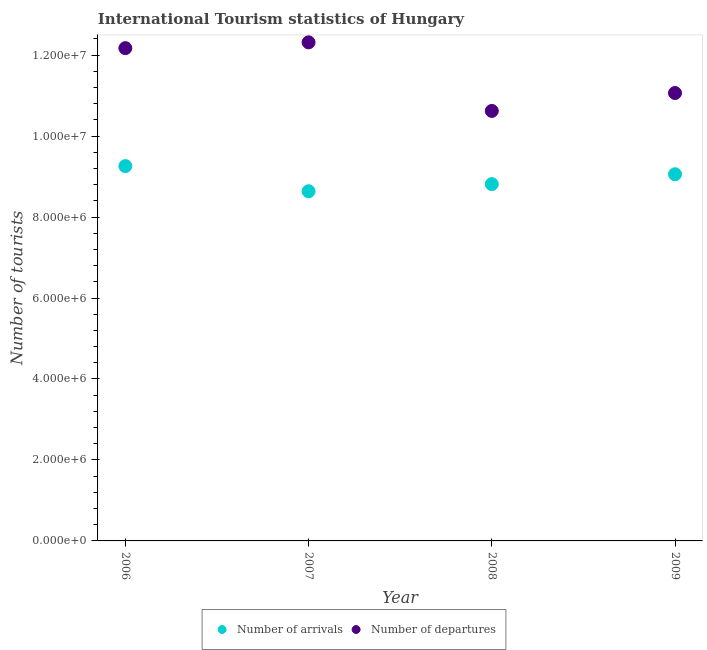Is the number of dotlines equal to the number of legend labels?
Offer a terse response. Yes. What is the number of tourist departures in 2006?
Offer a terse response. 1.22e+07. Across all years, what is the maximum number of tourist departures?
Keep it short and to the point. 1.23e+07. Across all years, what is the minimum number of tourist arrivals?
Your response must be concise. 8.64e+06. In which year was the number of tourist departures maximum?
Give a very brief answer. 2007. In which year was the number of tourist arrivals minimum?
Make the answer very short. 2007. What is the total number of tourist departures in the graph?
Offer a very short reply. 4.62e+07. What is the difference between the number of tourist departures in 2008 and that in 2009?
Provide a succinct answer. -4.43e+05. What is the difference between the number of tourist departures in 2008 and the number of tourist arrivals in 2009?
Your answer should be compact. 1.56e+06. What is the average number of tourist arrivals per year?
Offer a terse response. 8.94e+06. In the year 2008, what is the difference between the number of tourist departures and number of tourist arrivals?
Your answer should be very brief. 1.81e+06. In how many years, is the number of tourist arrivals greater than 10000000?
Give a very brief answer. 0. What is the ratio of the number of tourist departures in 2006 to that in 2009?
Give a very brief answer. 1.1. Is the number of tourist arrivals in 2007 less than that in 2009?
Give a very brief answer. Yes. What is the difference between the highest and the second highest number of tourist departures?
Keep it short and to the point. 1.44e+05. What is the difference between the highest and the lowest number of tourist departures?
Your answer should be very brief. 1.70e+06. In how many years, is the number of tourist departures greater than the average number of tourist departures taken over all years?
Make the answer very short. 2. Is the sum of the number of tourist departures in 2007 and 2008 greater than the maximum number of tourist arrivals across all years?
Provide a short and direct response. Yes. Is the number of tourist arrivals strictly less than the number of tourist departures over the years?
Ensure brevity in your answer.  Yes. How many dotlines are there?
Give a very brief answer. 2. How many legend labels are there?
Give a very brief answer. 2. What is the title of the graph?
Your answer should be compact. International Tourism statistics of Hungary. What is the label or title of the Y-axis?
Your response must be concise. Number of tourists. What is the Number of tourists in Number of arrivals in 2006?
Keep it short and to the point. 9.26e+06. What is the Number of tourists in Number of departures in 2006?
Keep it short and to the point. 1.22e+07. What is the Number of tourists in Number of arrivals in 2007?
Make the answer very short. 8.64e+06. What is the Number of tourists in Number of departures in 2007?
Offer a very short reply. 1.23e+07. What is the Number of tourists in Number of arrivals in 2008?
Your response must be concise. 8.81e+06. What is the Number of tourists of Number of departures in 2008?
Your response must be concise. 1.06e+07. What is the Number of tourists in Number of arrivals in 2009?
Offer a very short reply. 9.06e+06. What is the Number of tourists of Number of departures in 2009?
Provide a succinct answer. 1.11e+07. Across all years, what is the maximum Number of tourists in Number of arrivals?
Your answer should be compact. 9.26e+06. Across all years, what is the maximum Number of tourists in Number of departures?
Make the answer very short. 1.23e+07. Across all years, what is the minimum Number of tourists of Number of arrivals?
Your response must be concise. 8.64e+06. Across all years, what is the minimum Number of tourists in Number of departures?
Provide a short and direct response. 1.06e+07. What is the total Number of tourists in Number of arrivals in the graph?
Your answer should be compact. 3.58e+07. What is the total Number of tourists of Number of departures in the graph?
Offer a terse response. 4.62e+07. What is the difference between the Number of tourists in Number of arrivals in 2006 and that in 2007?
Your answer should be compact. 6.21e+05. What is the difference between the Number of tourists of Number of departures in 2006 and that in 2007?
Your response must be concise. -1.44e+05. What is the difference between the Number of tourists in Number of arrivals in 2006 and that in 2008?
Provide a succinct answer. 4.45e+05. What is the difference between the Number of tourists in Number of departures in 2006 and that in 2008?
Offer a very short reply. 1.55e+06. What is the difference between the Number of tourists of Number of arrivals in 2006 and that in 2009?
Provide a succinct answer. 2.01e+05. What is the difference between the Number of tourists of Number of departures in 2006 and that in 2009?
Keep it short and to the point. 1.11e+06. What is the difference between the Number of tourists in Number of arrivals in 2007 and that in 2008?
Your answer should be very brief. -1.76e+05. What is the difference between the Number of tourists in Number of departures in 2007 and that in 2008?
Ensure brevity in your answer.  1.70e+06. What is the difference between the Number of tourists of Number of arrivals in 2007 and that in 2009?
Keep it short and to the point. -4.20e+05. What is the difference between the Number of tourists of Number of departures in 2007 and that in 2009?
Ensure brevity in your answer.  1.25e+06. What is the difference between the Number of tourists in Number of arrivals in 2008 and that in 2009?
Offer a very short reply. -2.44e+05. What is the difference between the Number of tourists in Number of departures in 2008 and that in 2009?
Give a very brief answer. -4.43e+05. What is the difference between the Number of tourists of Number of arrivals in 2006 and the Number of tourists of Number of departures in 2007?
Keep it short and to the point. -3.06e+06. What is the difference between the Number of tourists in Number of arrivals in 2006 and the Number of tourists in Number of departures in 2008?
Ensure brevity in your answer.  -1.36e+06. What is the difference between the Number of tourists in Number of arrivals in 2006 and the Number of tourists in Number of departures in 2009?
Make the answer very short. -1.81e+06. What is the difference between the Number of tourists in Number of arrivals in 2007 and the Number of tourists in Number of departures in 2008?
Make the answer very short. -1.98e+06. What is the difference between the Number of tourists of Number of arrivals in 2007 and the Number of tourists of Number of departures in 2009?
Ensure brevity in your answer.  -2.43e+06. What is the difference between the Number of tourists of Number of arrivals in 2008 and the Number of tourists of Number of departures in 2009?
Your response must be concise. -2.25e+06. What is the average Number of tourists of Number of arrivals per year?
Ensure brevity in your answer.  8.94e+06. What is the average Number of tourists of Number of departures per year?
Provide a succinct answer. 1.15e+07. In the year 2006, what is the difference between the Number of tourists of Number of arrivals and Number of tourists of Number of departures?
Keep it short and to the point. -2.91e+06. In the year 2007, what is the difference between the Number of tourists in Number of arrivals and Number of tourists in Number of departures?
Ensure brevity in your answer.  -3.68e+06. In the year 2008, what is the difference between the Number of tourists in Number of arrivals and Number of tourists in Number of departures?
Offer a terse response. -1.81e+06. In the year 2009, what is the difference between the Number of tourists in Number of arrivals and Number of tourists in Number of departures?
Provide a short and direct response. -2.01e+06. What is the ratio of the Number of tourists in Number of arrivals in 2006 to that in 2007?
Ensure brevity in your answer.  1.07. What is the ratio of the Number of tourists of Number of departures in 2006 to that in 2007?
Keep it short and to the point. 0.99. What is the ratio of the Number of tourists of Number of arrivals in 2006 to that in 2008?
Make the answer very short. 1.05. What is the ratio of the Number of tourists in Number of departures in 2006 to that in 2008?
Make the answer very short. 1.15. What is the ratio of the Number of tourists in Number of arrivals in 2006 to that in 2009?
Your answer should be compact. 1.02. What is the ratio of the Number of tourists of Number of departures in 2006 to that in 2009?
Give a very brief answer. 1.1. What is the ratio of the Number of tourists in Number of departures in 2007 to that in 2008?
Make the answer very short. 1.16. What is the ratio of the Number of tourists of Number of arrivals in 2007 to that in 2009?
Keep it short and to the point. 0.95. What is the ratio of the Number of tourists of Number of departures in 2007 to that in 2009?
Your answer should be very brief. 1.11. What is the ratio of the Number of tourists in Number of arrivals in 2008 to that in 2009?
Your answer should be very brief. 0.97. What is the ratio of the Number of tourists of Number of departures in 2008 to that in 2009?
Your answer should be very brief. 0.96. What is the difference between the highest and the second highest Number of tourists in Number of arrivals?
Offer a terse response. 2.01e+05. What is the difference between the highest and the second highest Number of tourists of Number of departures?
Your answer should be compact. 1.44e+05. What is the difference between the highest and the lowest Number of tourists in Number of arrivals?
Your answer should be compact. 6.21e+05. What is the difference between the highest and the lowest Number of tourists in Number of departures?
Provide a short and direct response. 1.70e+06. 